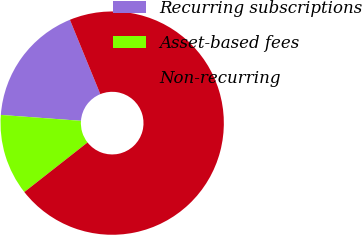<chart> <loc_0><loc_0><loc_500><loc_500><pie_chart><fcel>Recurring subscriptions<fcel>Asset-based fees<fcel>Non-recurring<nl><fcel>17.65%<fcel>11.76%<fcel>70.59%<nl></chart> 